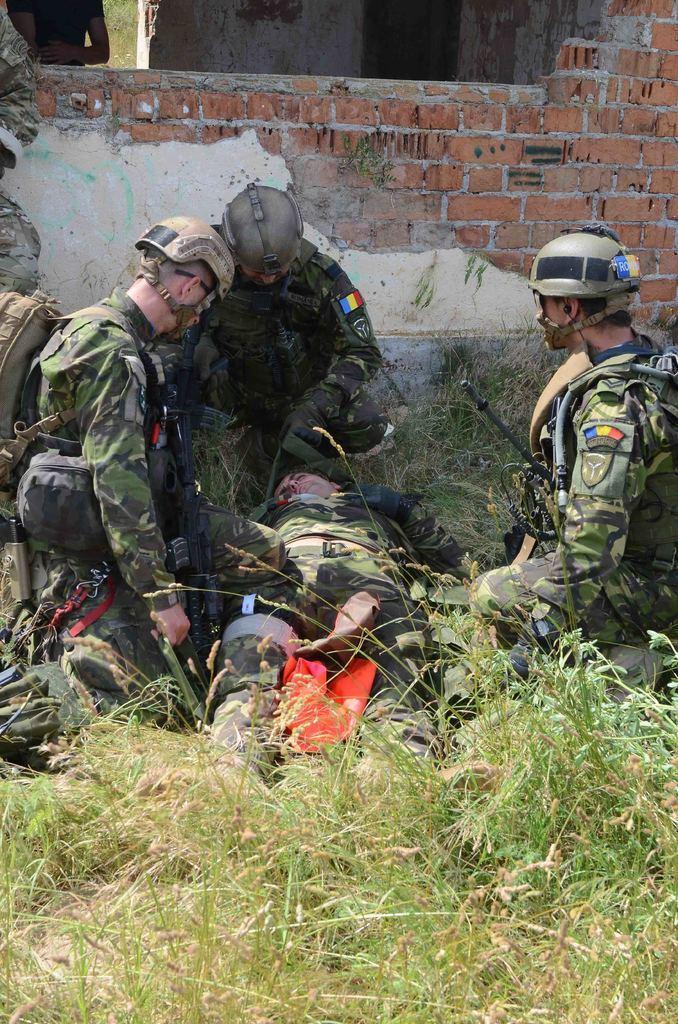Please provide a concise description of this image. On the left side, there are two persons in uniform. Beside them, there is a person in uniform lying on the ground, on which there is grass. On the right side, there is another person in uniform, squirting on the ground. In the background, there is a person in a building which is having brick wall and there's grass on the ground. 